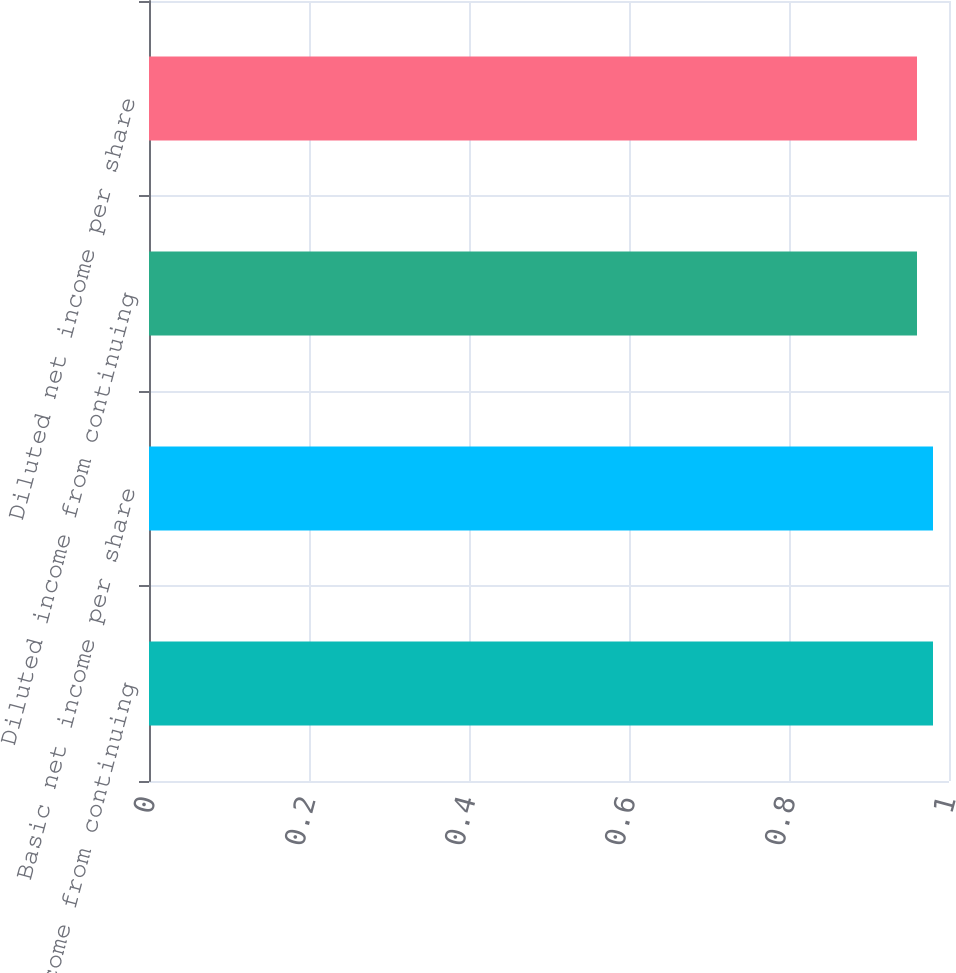Convert chart. <chart><loc_0><loc_0><loc_500><loc_500><bar_chart><fcel>Basic income from continuing<fcel>Basic net income per share<fcel>Diluted income from continuing<fcel>Diluted net income per share<nl><fcel>0.98<fcel>0.98<fcel>0.96<fcel>0.96<nl></chart> 